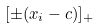<formula> <loc_0><loc_0><loc_500><loc_500>[ \pm ( x _ { i } - c ) ] _ { + }</formula> 